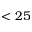<formula> <loc_0><loc_0><loc_500><loc_500>< 2 5</formula> 